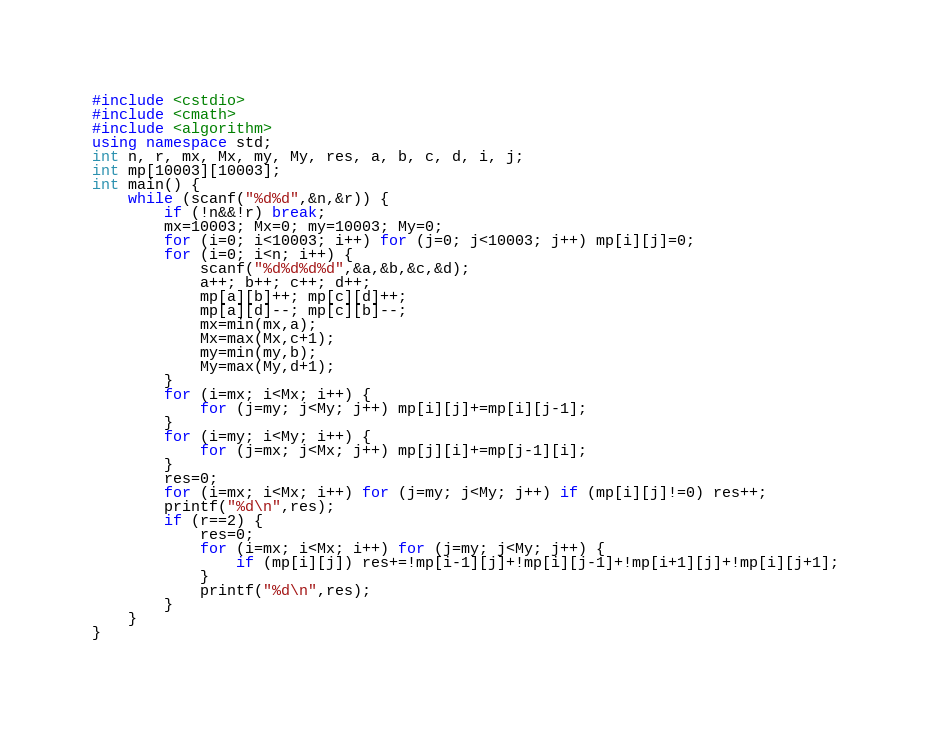<code> <loc_0><loc_0><loc_500><loc_500><_C++_>#include <cstdio>
#include <cmath>
#include <algorithm>
using namespace std;
int n, r, mx, Mx, my, My, res, a, b, c, d, i, j;
int mp[10003][10003];
int main() {
    while (scanf("%d%d",&n,&r)) {
        if (!n&&!r) break;
        mx=10003; Mx=0; my=10003; My=0;
        for (i=0; i<10003; i++) for (j=0; j<10003; j++) mp[i][j]=0;
        for (i=0; i<n; i++) {
            scanf("%d%d%d%d",&a,&b,&c,&d);
            a++; b++; c++; d++;
            mp[a][b]++; mp[c][d]++;
            mp[a][d]--; mp[c][b]--;
            mx=min(mx,a);
            Mx=max(Mx,c+1);
            my=min(my,b);
            My=max(My,d+1);
        }
        for (i=mx; i<Mx; i++) {
            for (j=my; j<My; j++) mp[i][j]+=mp[i][j-1];
        }
        for (i=my; i<My; i++) {
            for (j=mx; j<Mx; j++) mp[j][i]+=mp[j-1][i];
        }
        res=0;
        for (i=mx; i<Mx; i++) for (j=my; j<My; j++) if (mp[i][j]!=0) res++;
        printf("%d\n",res);
        if (r==2) {
            res=0;
            for (i=mx; i<Mx; i++) for (j=my; j<My; j++) {
                if (mp[i][j]) res+=!mp[i-1][j]+!mp[i][j-1]+!mp[i+1][j]+!mp[i][j+1];
            }
            printf("%d\n",res);
        }
    }
}</code> 